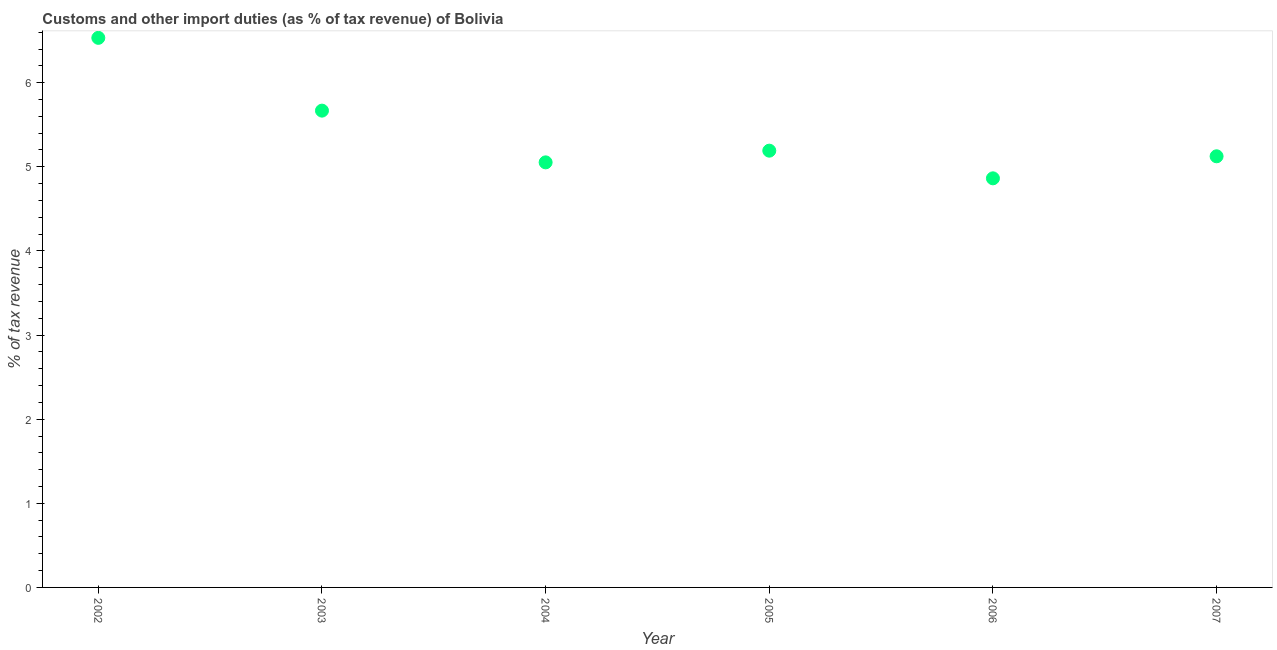What is the customs and other import duties in 2007?
Your answer should be very brief. 5.13. Across all years, what is the maximum customs and other import duties?
Your response must be concise. 6.53. Across all years, what is the minimum customs and other import duties?
Offer a very short reply. 4.86. In which year was the customs and other import duties maximum?
Make the answer very short. 2002. What is the sum of the customs and other import duties?
Keep it short and to the point. 32.43. What is the difference between the customs and other import duties in 2003 and 2006?
Keep it short and to the point. 0.8. What is the average customs and other import duties per year?
Your response must be concise. 5.41. What is the median customs and other import duties?
Ensure brevity in your answer.  5.16. Do a majority of the years between 2002 and 2006 (inclusive) have customs and other import duties greater than 5.4 %?
Make the answer very short. No. What is the ratio of the customs and other import duties in 2002 to that in 2004?
Ensure brevity in your answer.  1.29. Is the difference between the customs and other import duties in 2002 and 2007 greater than the difference between any two years?
Offer a very short reply. No. What is the difference between the highest and the second highest customs and other import duties?
Provide a short and direct response. 0.87. Is the sum of the customs and other import duties in 2002 and 2007 greater than the maximum customs and other import duties across all years?
Make the answer very short. Yes. What is the difference between the highest and the lowest customs and other import duties?
Offer a very short reply. 1.67. How many years are there in the graph?
Provide a succinct answer. 6. What is the difference between two consecutive major ticks on the Y-axis?
Offer a very short reply. 1. Does the graph contain any zero values?
Your answer should be compact. No. Does the graph contain grids?
Offer a terse response. No. What is the title of the graph?
Keep it short and to the point. Customs and other import duties (as % of tax revenue) of Bolivia. What is the label or title of the Y-axis?
Your answer should be very brief. % of tax revenue. What is the % of tax revenue in 2002?
Your response must be concise. 6.53. What is the % of tax revenue in 2003?
Give a very brief answer. 5.67. What is the % of tax revenue in 2004?
Provide a short and direct response. 5.05. What is the % of tax revenue in 2005?
Your answer should be compact. 5.19. What is the % of tax revenue in 2006?
Ensure brevity in your answer.  4.86. What is the % of tax revenue in 2007?
Make the answer very short. 5.13. What is the difference between the % of tax revenue in 2002 and 2003?
Provide a short and direct response. 0.87. What is the difference between the % of tax revenue in 2002 and 2004?
Your response must be concise. 1.48. What is the difference between the % of tax revenue in 2002 and 2005?
Your response must be concise. 1.34. What is the difference between the % of tax revenue in 2002 and 2006?
Provide a succinct answer. 1.67. What is the difference between the % of tax revenue in 2002 and 2007?
Offer a very short reply. 1.41. What is the difference between the % of tax revenue in 2003 and 2004?
Keep it short and to the point. 0.61. What is the difference between the % of tax revenue in 2003 and 2005?
Make the answer very short. 0.48. What is the difference between the % of tax revenue in 2003 and 2006?
Give a very brief answer. 0.8. What is the difference between the % of tax revenue in 2003 and 2007?
Your answer should be compact. 0.54. What is the difference between the % of tax revenue in 2004 and 2005?
Give a very brief answer. -0.14. What is the difference between the % of tax revenue in 2004 and 2006?
Offer a terse response. 0.19. What is the difference between the % of tax revenue in 2004 and 2007?
Your response must be concise. -0.07. What is the difference between the % of tax revenue in 2005 and 2006?
Your answer should be very brief. 0.33. What is the difference between the % of tax revenue in 2005 and 2007?
Give a very brief answer. 0.07. What is the difference between the % of tax revenue in 2006 and 2007?
Your answer should be compact. -0.26. What is the ratio of the % of tax revenue in 2002 to that in 2003?
Keep it short and to the point. 1.15. What is the ratio of the % of tax revenue in 2002 to that in 2004?
Keep it short and to the point. 1.29. What is the ratio of the % of tax revenue in 2002 to that in 2005?
Give a very brief answer. 1.26. What is the ratio of the % of tax revenue in 2002 to that in 2006?
Your response must be concise. 1.34. What is the ratio of the % of tax revenue in 2002 to that in 2007?
Offer a terse response. 1.27. What is the ratio of the % of tax revenue in 2003 to that in 2004?
Provide a short and direct response. 1.12. What is the ratio of the % of tax revenue in 2003 to that in 2005?
Your answer should be very brief. 1.09. What is the ratio of the % of tax revenue in 2003 to that in 2006?
Provide a short and direct response. 1.17. What is the ratio of the % of tax revenue in 2003 to that in 2007?
Your answer should be compact. 1.11. What is the ratio of the % of tax revenue in 2004 to that in 2006?
Your answer should be compact. 1.04. What is the ratio of the % of tax revenue in 2005 to that in 2006?
Keep it short and to the point. 1.07. What is the ratio of the % of tax revenue in 2006 to that in 2007?
Make the answer very short. 0.95. 